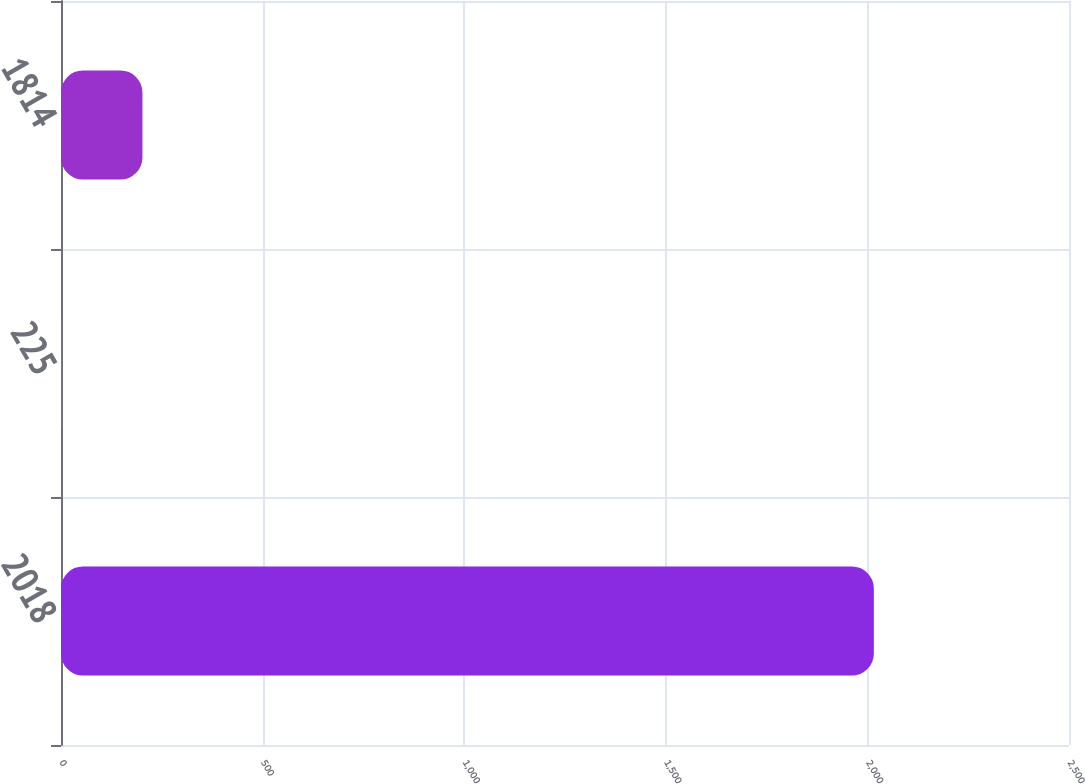Convert chart. <chart><loc_0><loc_0><loc_500><loc_500><bar_chart><fcel>2018<fcel>225<fcel>1814<nl><fcel>2016<fcel>0.44<fcel>202<nl></chart> 